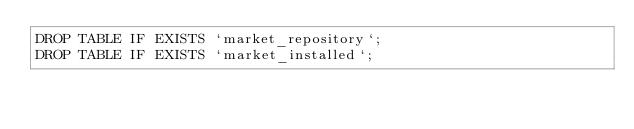Convert code to text. <code><loc_0><loc_0><loc_500><loc_500><_SQL_>DROP TABLE IF EXISTS `market_repository`;
DROP TABLE IF EXISTS `market_installed`;</code> 